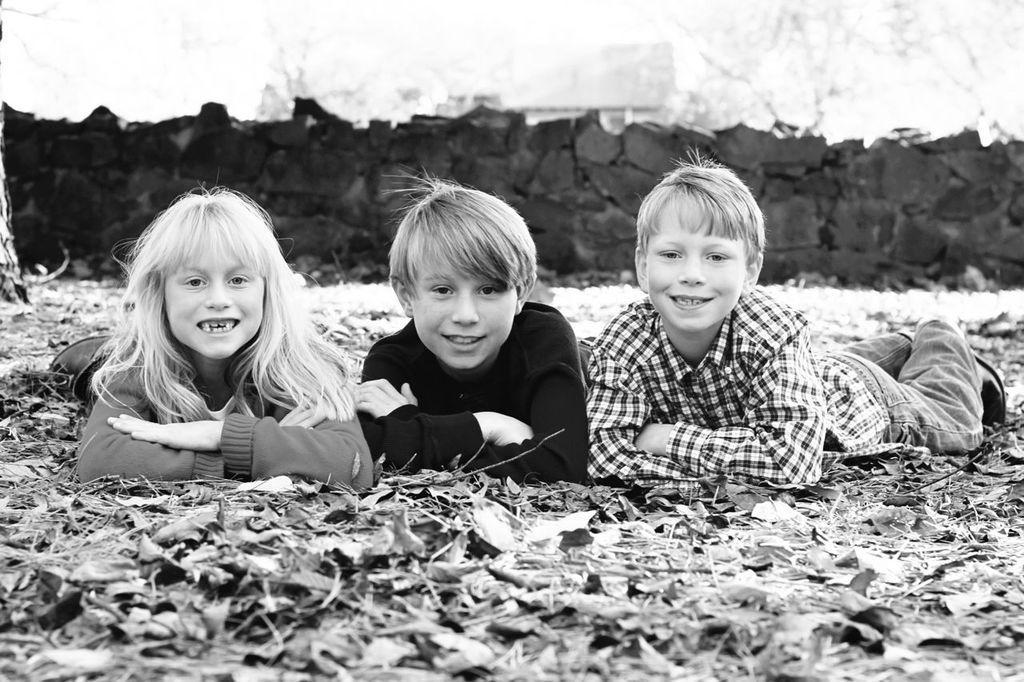In one or two sentences, can you explain what this image depicts? In this image there are children's laying on ground and I can see the stone wall at the top. 